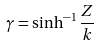Convert formula to latex. <formula><loc_0><loc_0><loc_500><loc_500>\gamma = \sinh ^ { - 1 } \frac { Z } { k }</formula> 